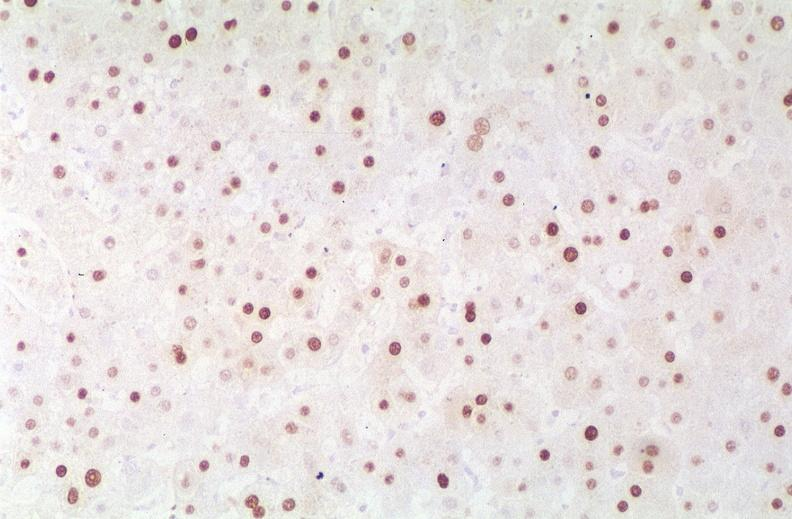what is present?
Answer the question using a single word or phrase. Hepatobiliary 